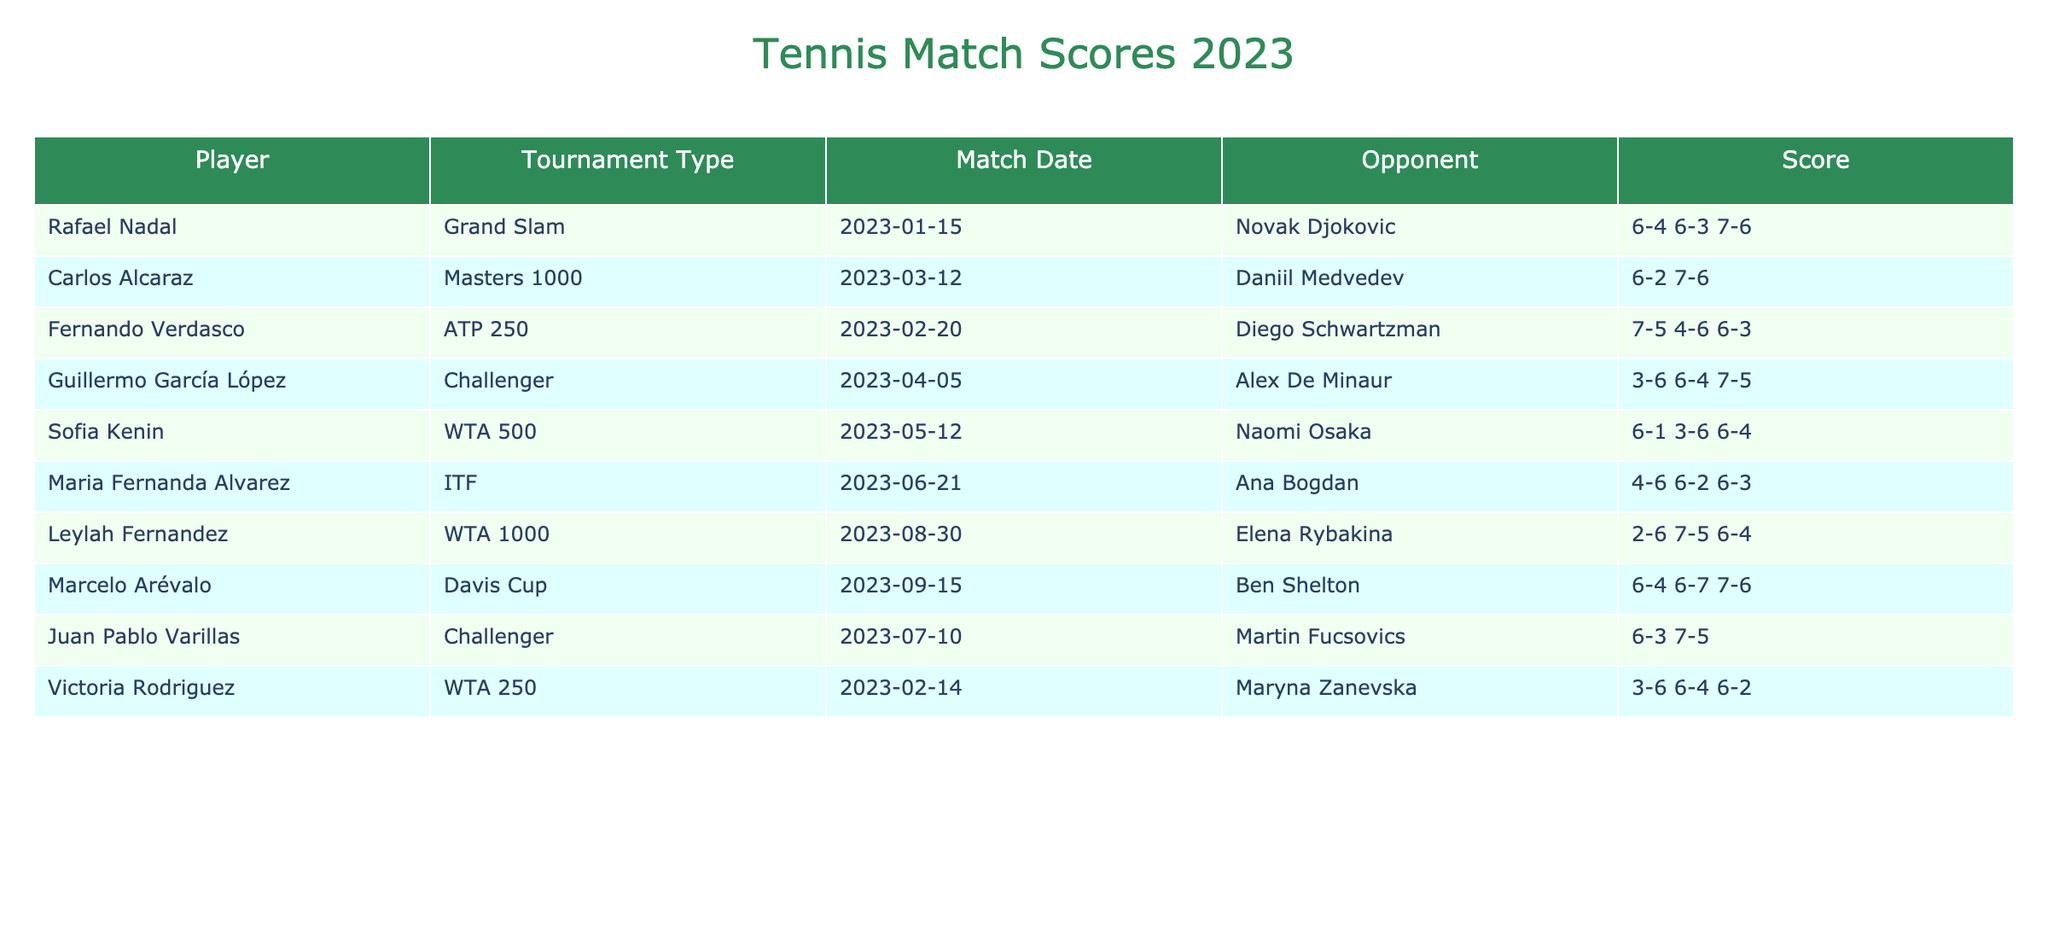What was the score of Rafael Nadal's match against Novak Djokovic? The table shows that Rafael Nadal played against Novak Djokovic and the score was 6-4, 6-3, 7-6.
Answer: 6-4, 6-3, 7-6 Which player won their match on June 21, 2023? The match on June 21 involved Maria Fernanda Alvarez against Ana Bogdan. The score indicates Alvarez won by 4-6, 6-2, 6-3.
Answer: Maria Fernanda Alvarez How many sets did Carlos Alcaraz play against Daniil Medvedev? The score for Carlos Alcaraz's match is 6-2, 7-6, which indicates he played 2 sets as the second set was a tie-break.
Answer: 2 sets Did Leylah Fernandez manage to win her match? In her match, Leylah Fernandez scored 2-6, 7-5, 6-4, which means she won after losing the first set.
Answer: Yes How many players participated in the ATP 250 tournament based on this table? The table lists only one ATP 250 match involving Fernando Verdasco.
Answer: 1 player What was the outcome of the match between Marcelo Arévalo and Ben Shelton? The score in that match was 6-4, 6-7, 7-6, indicating that Marcelo Arévalo won the match in the deciding set after a tiebreak.
Answer: Marcelo Arévalo won Which player had the longest match in terms of sets? The match involving Marcelo Arévalo and Ben Shelton had a score of 6-4, 6-7, 7-6, meaning it went to 3 sets. No other match had more than 3 sets.
Answer: Marcelo Arévalo vs. Ben Shelton Was Fernando Verdasco's match the only one that went to three sets? The score of Fernando Verdasco's match shows it went to three sets (7-5, 4-6, 6-3), but the match between Marcelo Arévalo and Ben Shelton also went to three sets.
Answer: No How many WTA matches are represented in the table? The table lists three WTA matches: one by Sofia Kenin, one by Leylah Fernandez, and one by Victoria Rodriguez.
Answer: 3 matches What percentage of the listed matches were Grand Slam events? There is one Grand Slam match (Rafael Nadal) out of a total of 10 matches in the table. Thus, the percentage is (1/10)*100 = 10%.
Answer: 10% 